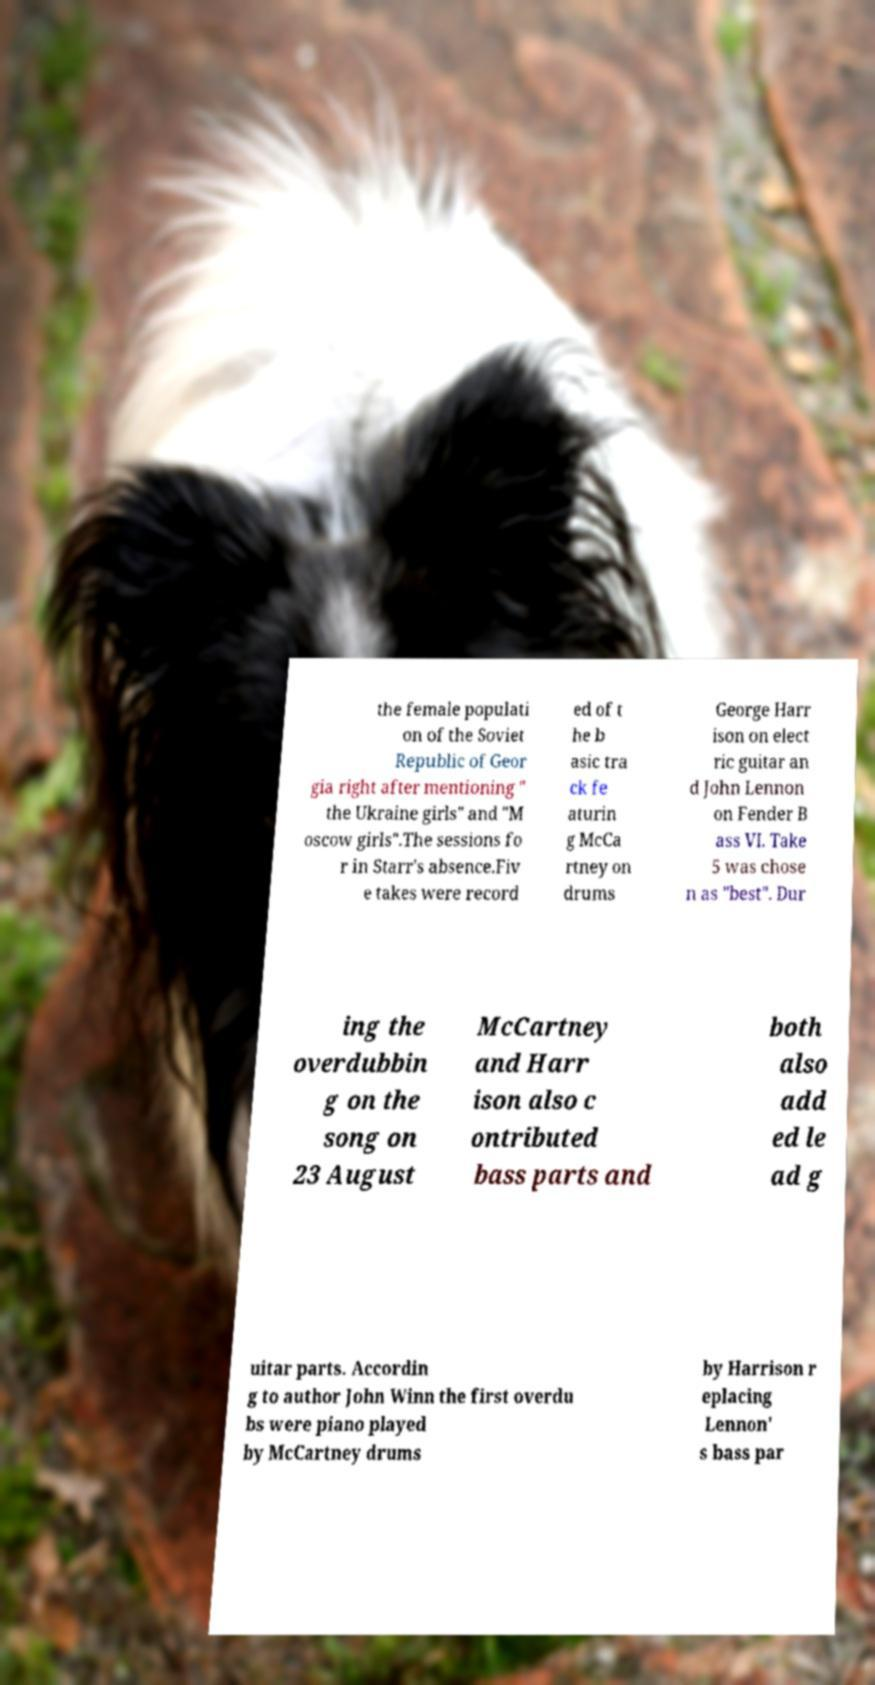Could you extract and type out the text from this image? the female populati on of the Soviet Republic of Geor gia right after mentioning " the Ukraine girls" and "M oscow girls".The sessions fo r in Starr's absence.Fiv e takes were record ed of t he b asic tra ck fe aturin g McCa rtney on drums George Harr ison on elect ric guitar an d John Lennon on Fender B ass VI. Take 5 was chose n as "best". Dur ing the overdubbin g on the song on 23 August McCartney and Harr ison also c ontributed bass parts and both also add ed le ad g uitar parts. Accordin g to author John Winn the first overdu bs were piano played by McCartney drums by Harrison r eplacing Lennon' s bass par 